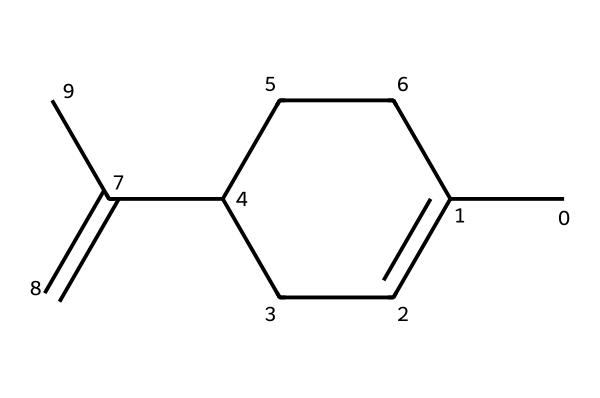What is the primary functional group present in this molecule? The structure contains a double bond (C=C), indicating the presence of an alkene functional group. Such a feature is commonly associated with many flavorful compounds.
Answer: alkene How many carbon atoms are in the molecular structure? By counting the visible carbon atoms in the structure, there are a total of 10 carbons, indicated by the connectivity and branching in the given SMILES representation.
Answer: 10 What type of molecule is this, based on its structure? The overall structure reflects a monoterpene, which is indicated by the cyclic and branched nature of the carbon backbone. This is characteristic of many essential oils, including those found in lavender.
Answer: monoterpene How many double bonds does this molecule contain? Analyzing the structure, there is one double bond indicated by the double line connecting two carbon atoms, which signifies a single C=C bond in the molecular structure.
Answer: 1 What are the primary characteristics of the molecule that might contribute to stress relief? The presence of a unique carbon structure along with the alkene suggests properties such as pleasant aroma and interactions with the olfactory system, commonly associated with calming and stress-relieving effects.
Answer: pleasant aroma 